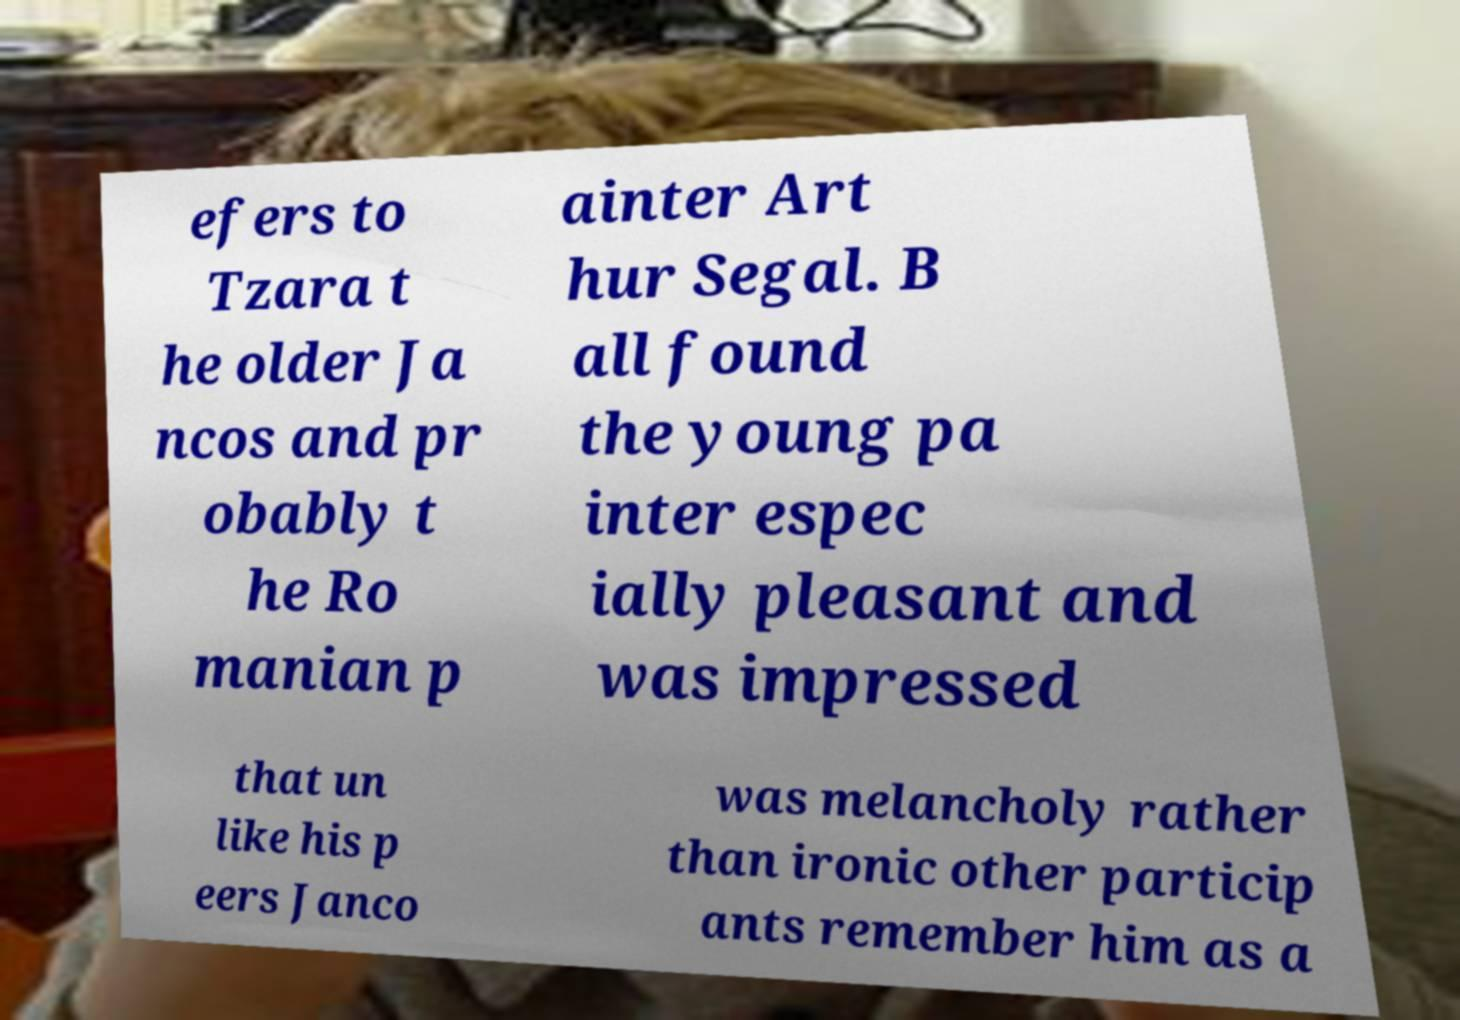There's text embedded in this image that I need extracted. Can you transcribe it verbatim? efers to Tzara t he older Ja ncos and pr obably t he Ro manian p ainter Art hur Segal. B all found the young pa inter espec ially pleasant and was impressed that un like his p eers Janco was melancholy rather than ironic other particip ants remember him as a 